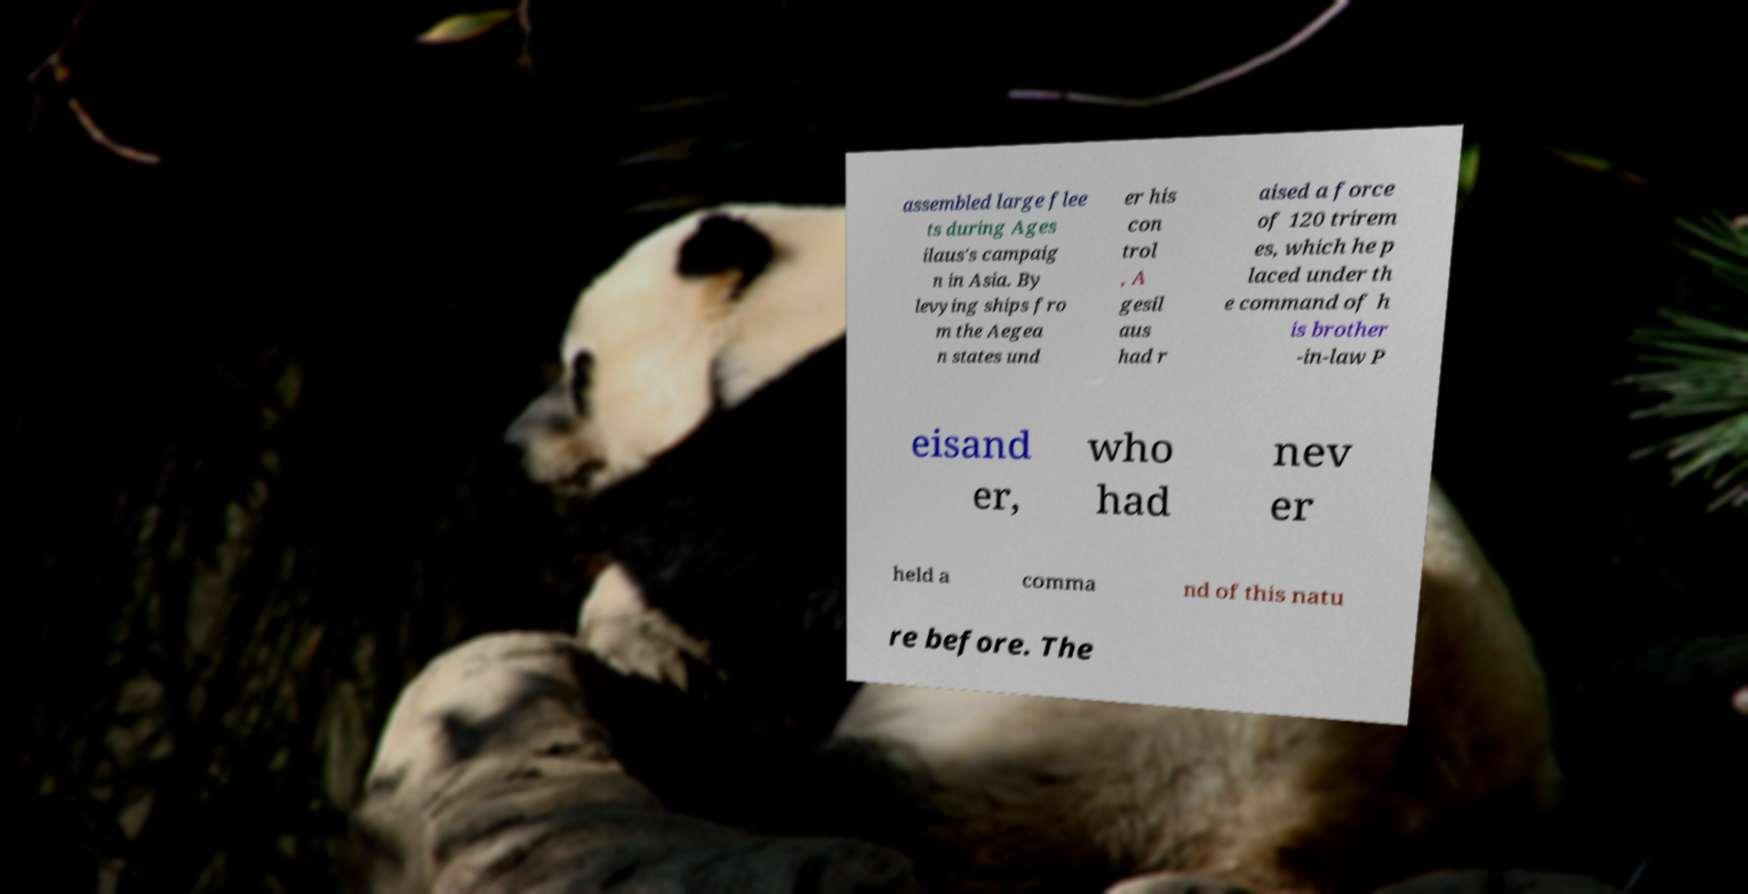For documentation purposes, I need the text within this image transcribed. Could you provide that? assembled large flee ts during Ages ilaus's campaig n in Asia. By levying ships fro m the Aegea n states und er his con trol , A gesil aus had r aised a force of 120 trirem es, which he p laced under th e command of h is brother -in-law P eisand er, who had nev er held a comma nd of this natu re before. The 